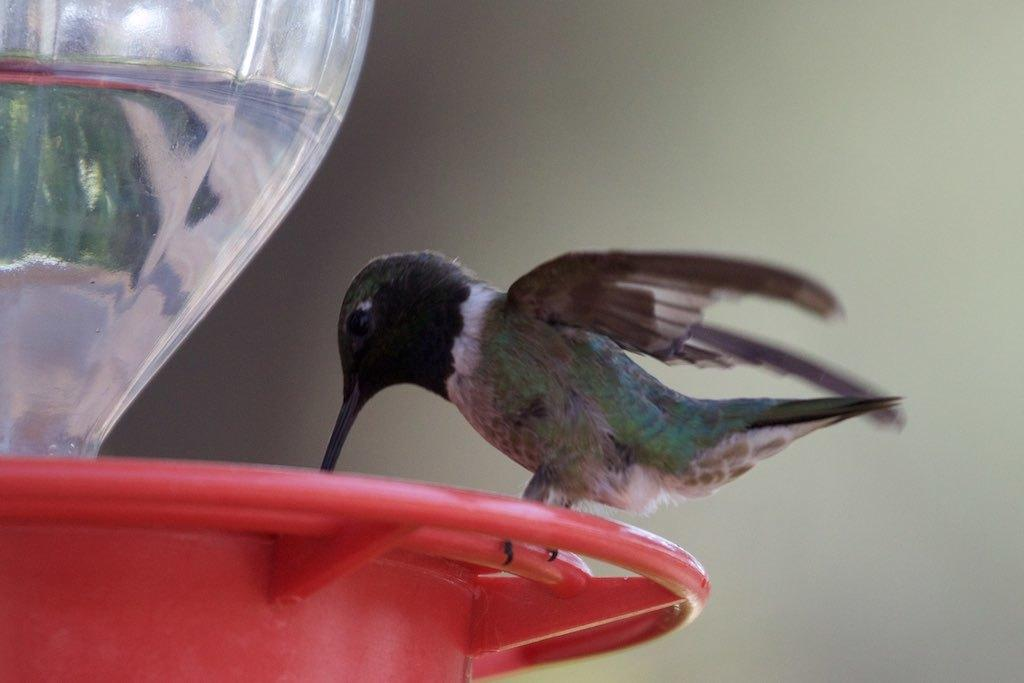What type of animal is in the image? There is a bird in the image. What is the bird sitting on? The bird is on a red object. What can be seen inside a container in the image? There is water in a glass jar in the image. Can you describe the background of the image? The background of the image is not clear. What type of powder is being used to create the level effect on the bird in the image? There is no powder or level effect present in the image; it features a bird sitting on a red object and water in a glass jar. 